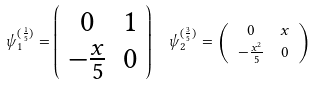<formula> <loc_0><loc_0><loc_500><loc_500>\psi _ { 1 } ^ { ( \frac { 1 } { 5 } ) } = \left ( \begin{array} { c c } 0 & 1 \\ - \frac { x } { 5 } & 0 \end{array} \right ) & \quad \psi _ { 2 } ^ { ( \frac { 3 } { 5 } ) } = \left ( \begin{array} { c c } 0 & x \\ - \frac { x ^ { 2 } } { 5 } & 0 \end{array} \right )</formula> 